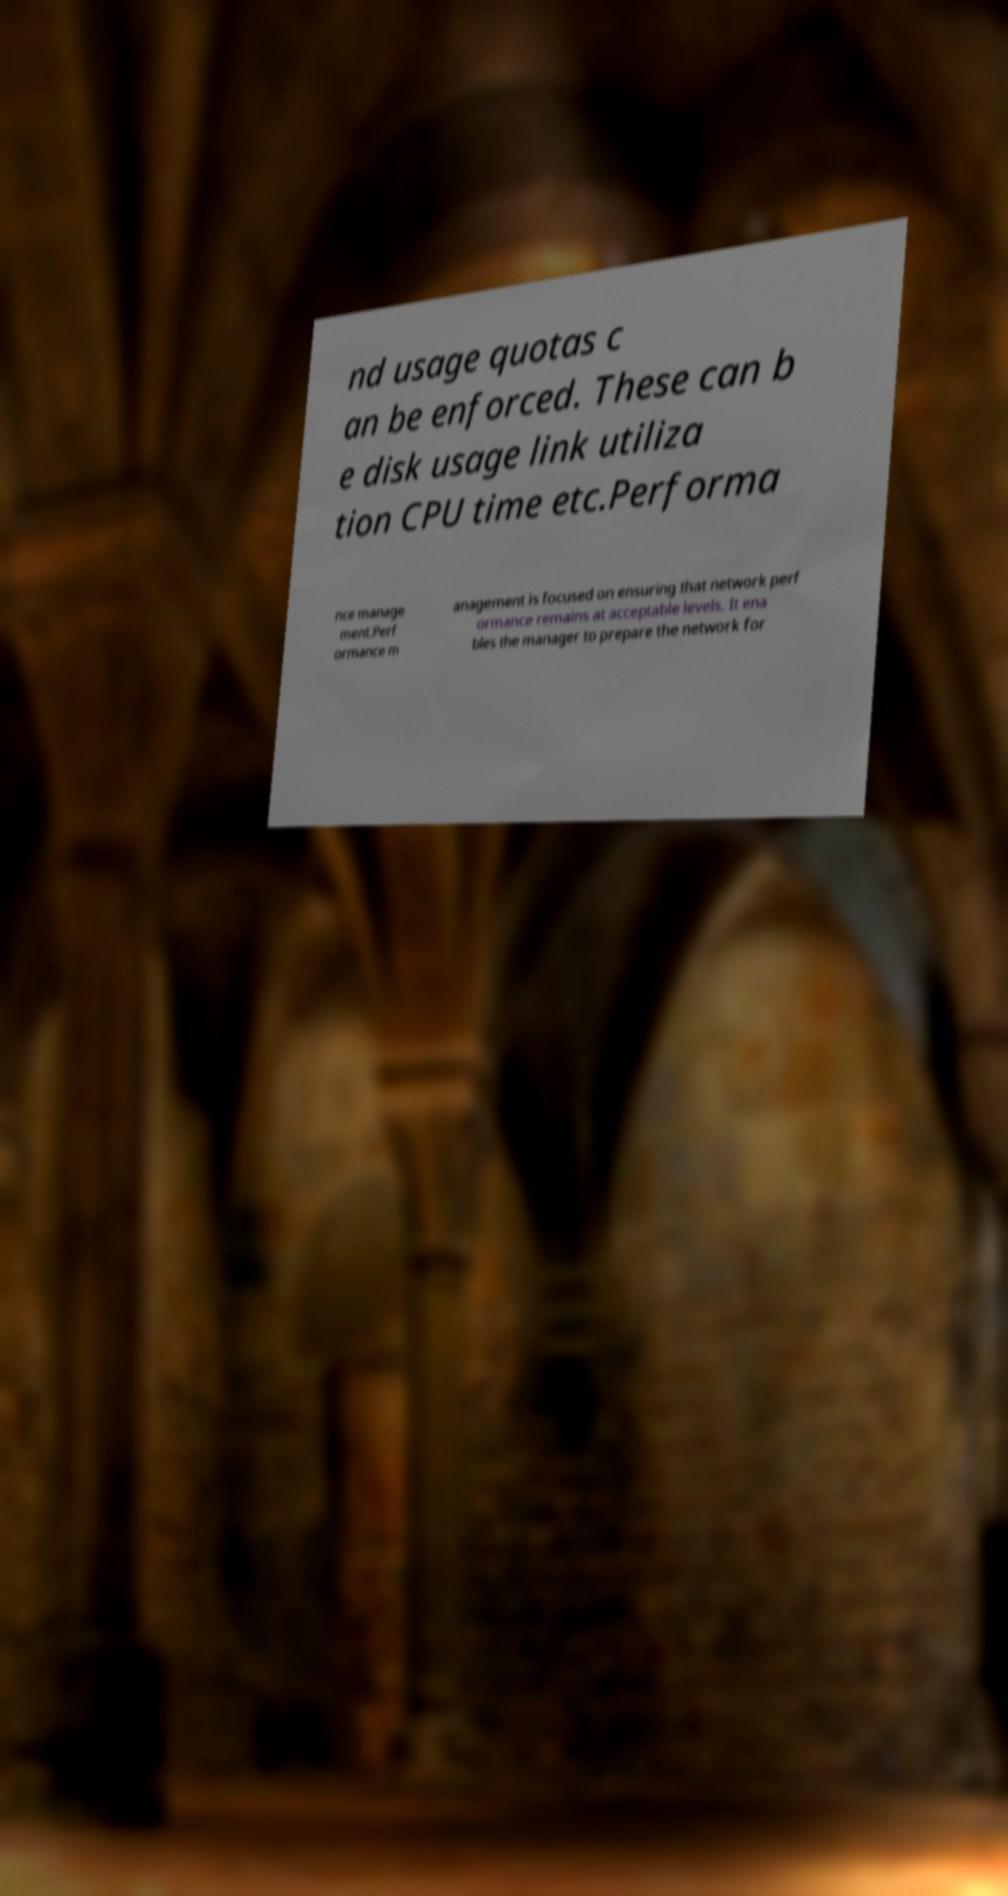Could you assist in decoding the text presented in this image and type it out clearly? nd usage quotas c an be enforced. These can b e disk usage link utiliza tion CPU time etc.Performa nce manage ment.Perf ormance m anagement is focused on ensuring that network perf ormance remains at acceptable levels. It ena bles the manager to prepare the network for 